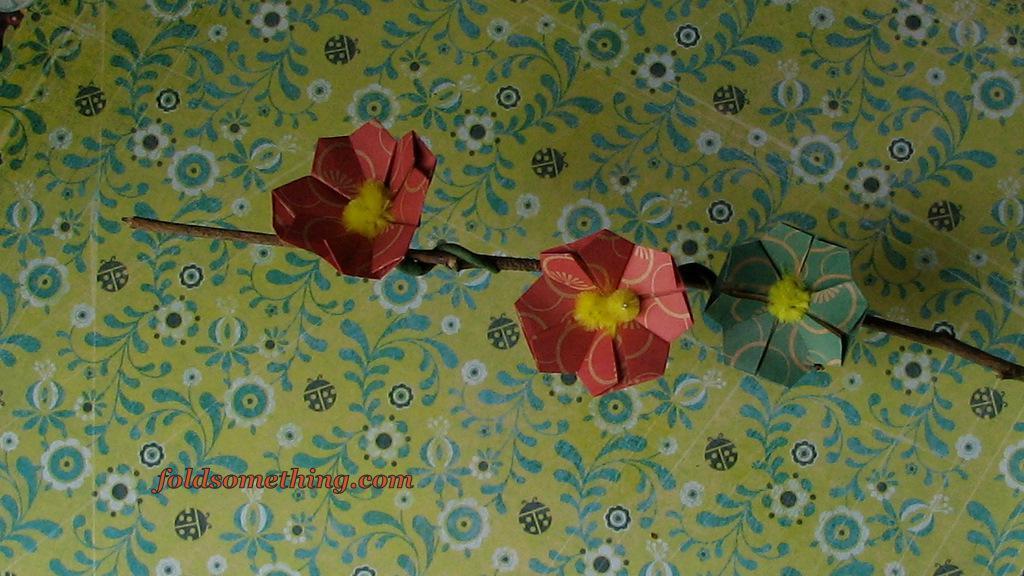Could you give a brief overview of what you see in this image? In this image I can see three papers flowers, they are in red, yellow and green color. Background I can see a colorful cloth. 